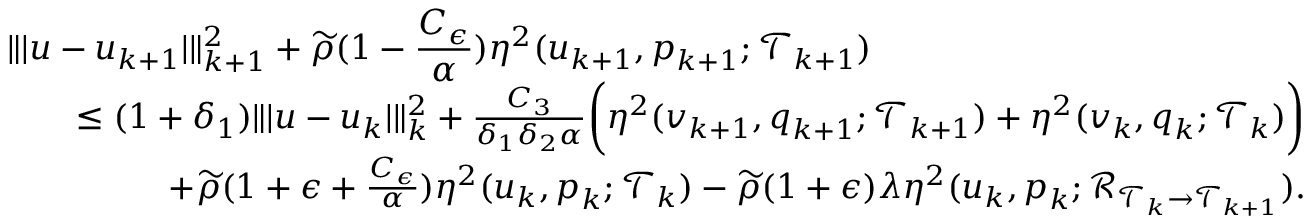Convert formula to latex. <formula><loc_0><loc_0><loc_500><loc_500>\begin{array} { r l r } { { \| | u - u _ { k + 1 } | \| _ { k + 1 } ^ { 2 } + \widetilde { \rho } ( 1 - \frac { C _ { \epsilon } } { \alpha } ) \eta ^ { 2 } ( u _ { k + 1 } , p _ { k + 1 } ; \mathcal { T } _ { k + 1 } ) } } \\ & { \leq ( 1 + \delta _ { 1 } ) \| | u - u _ { k } | \| _ { k } ^ { 2 } + \frac { C _ { 3 } } { \delta _ { 1 } \delta _ { 2 } \alpha } \left ( \eta ^ { 2 } ( v _ { k + 1 } , q _ { k + 1 } ; \mathcal { T } _ { k + 1 } ) + \eta ^ { 2 } ( v _ { k } , q _ { k } ; \mathcal { T } _ { k } ) \right ) } \\ & { \quad + \widetilde { \rho } ( 1 + \epsilon + \frac { C _ { \epsilon } } { \alpha } ) \eta ^ { 2 } ( u _ { k } , p _ { k } ; \mathcal { T } _ { k } ) - \widetilde { \rho } ( 1 + \epsilon ) \lambda \eta ^ { 2 } ( u _ { k } , p _ { k } ; \mathcal { R } _ { \mathcal { T } _ { k } \rightarrow \mathcal { T } _ { k + 1 } } ) . } \end{array}</formula> 